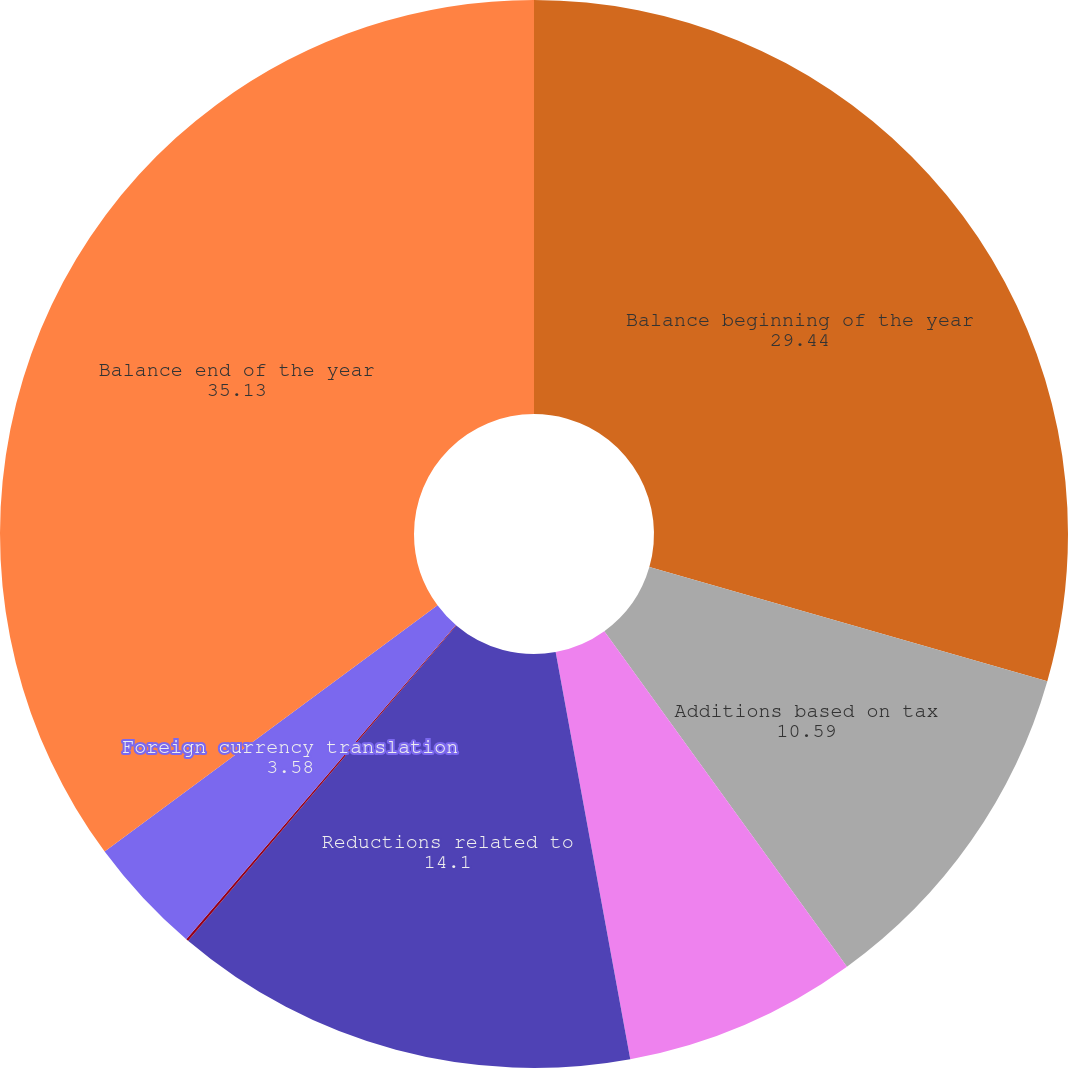Convert chart to OTSL. <chart><loc_0><loc_0><loc_500><loc_500><pie_chart><fcel>Balance beginning of the year<fcel>Additions based on tax<fcel>Reductions based on tax<fcel>Reductions related to<fcel>Expiration of statute of<fcel>Foreign currency translation<fcel>Balance end of the year<nl><fcel>29.44%<fcel>10.59%<fcel>7.08%<fcel>14.1%<fcel>0.07%<fcel>3.58%<fcel>35.13%<nl></chart> 